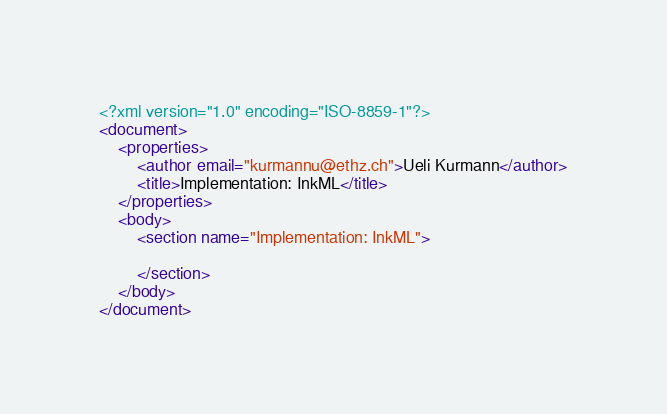<code> <loc_0><loc_0><loc_500><loc_500><_XML_><?xml version="1.0" encoding="ISO-8859-1"?>
<document>
	<properties>
		<author email="kurmannu@ethz.ch">Ueli Kurmann</author>
		<title>Implementation: InkML</title>
	</properties>
	<body>
		<section name="Implementation: InkML">

		</section>
	</body>
</document></code> 